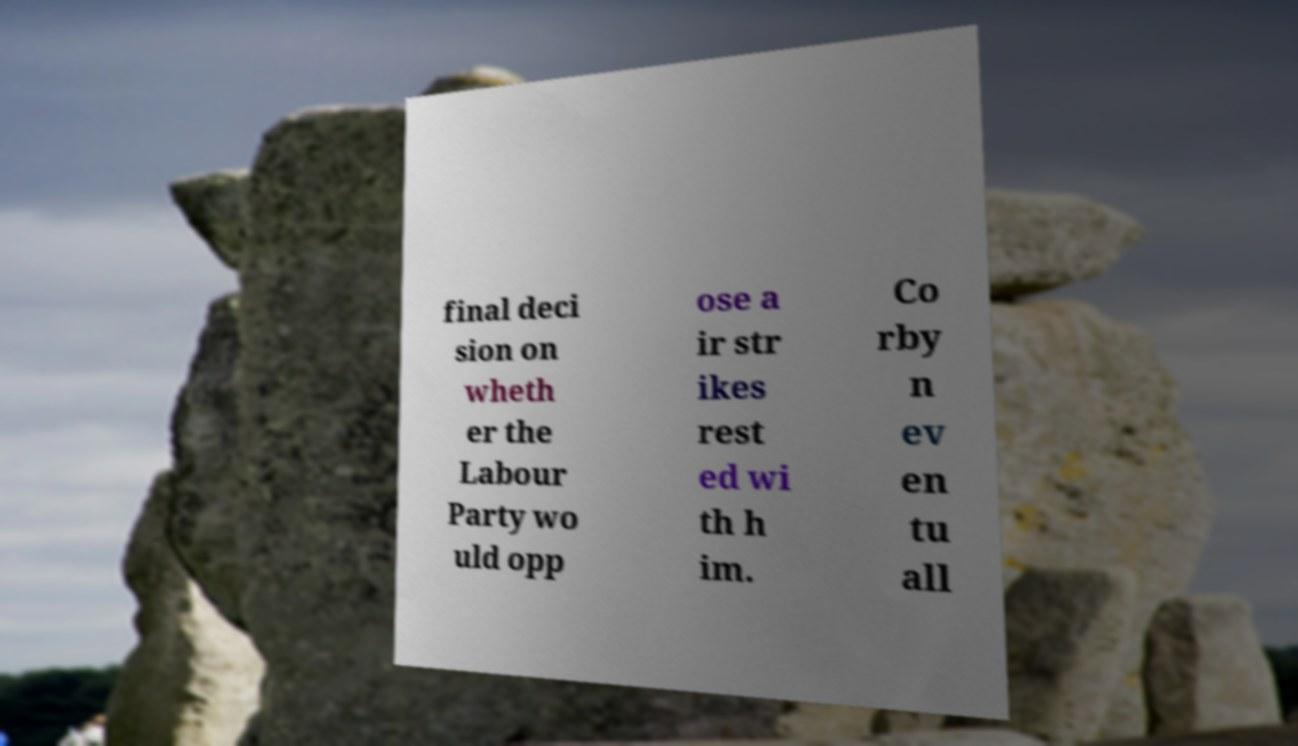Please read and relay the text visible in this image. What does it say? final deci sion on wheth er the Labour Party wo uld opp ose a ir str ikes rest ed wi th h im. Co rby n ev en tu all 